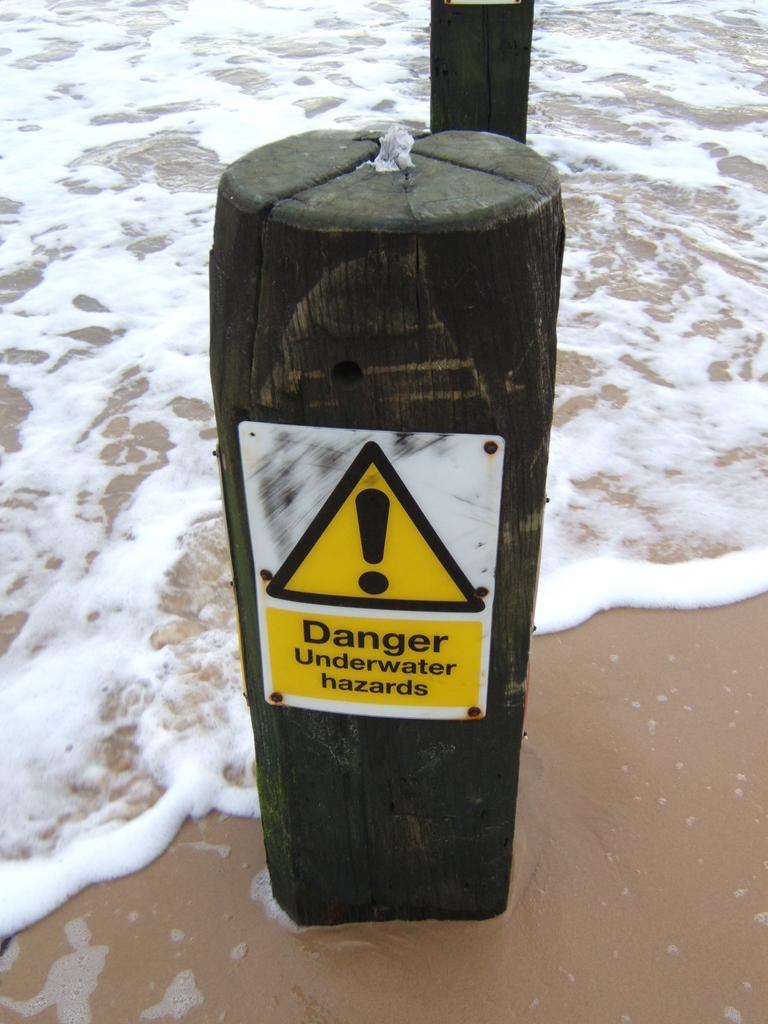Provide a one-sentence caption for the provided image. A large log on the beach, where the tide is rolling in, has a danger sign on it, warning people of underwater hazards. 